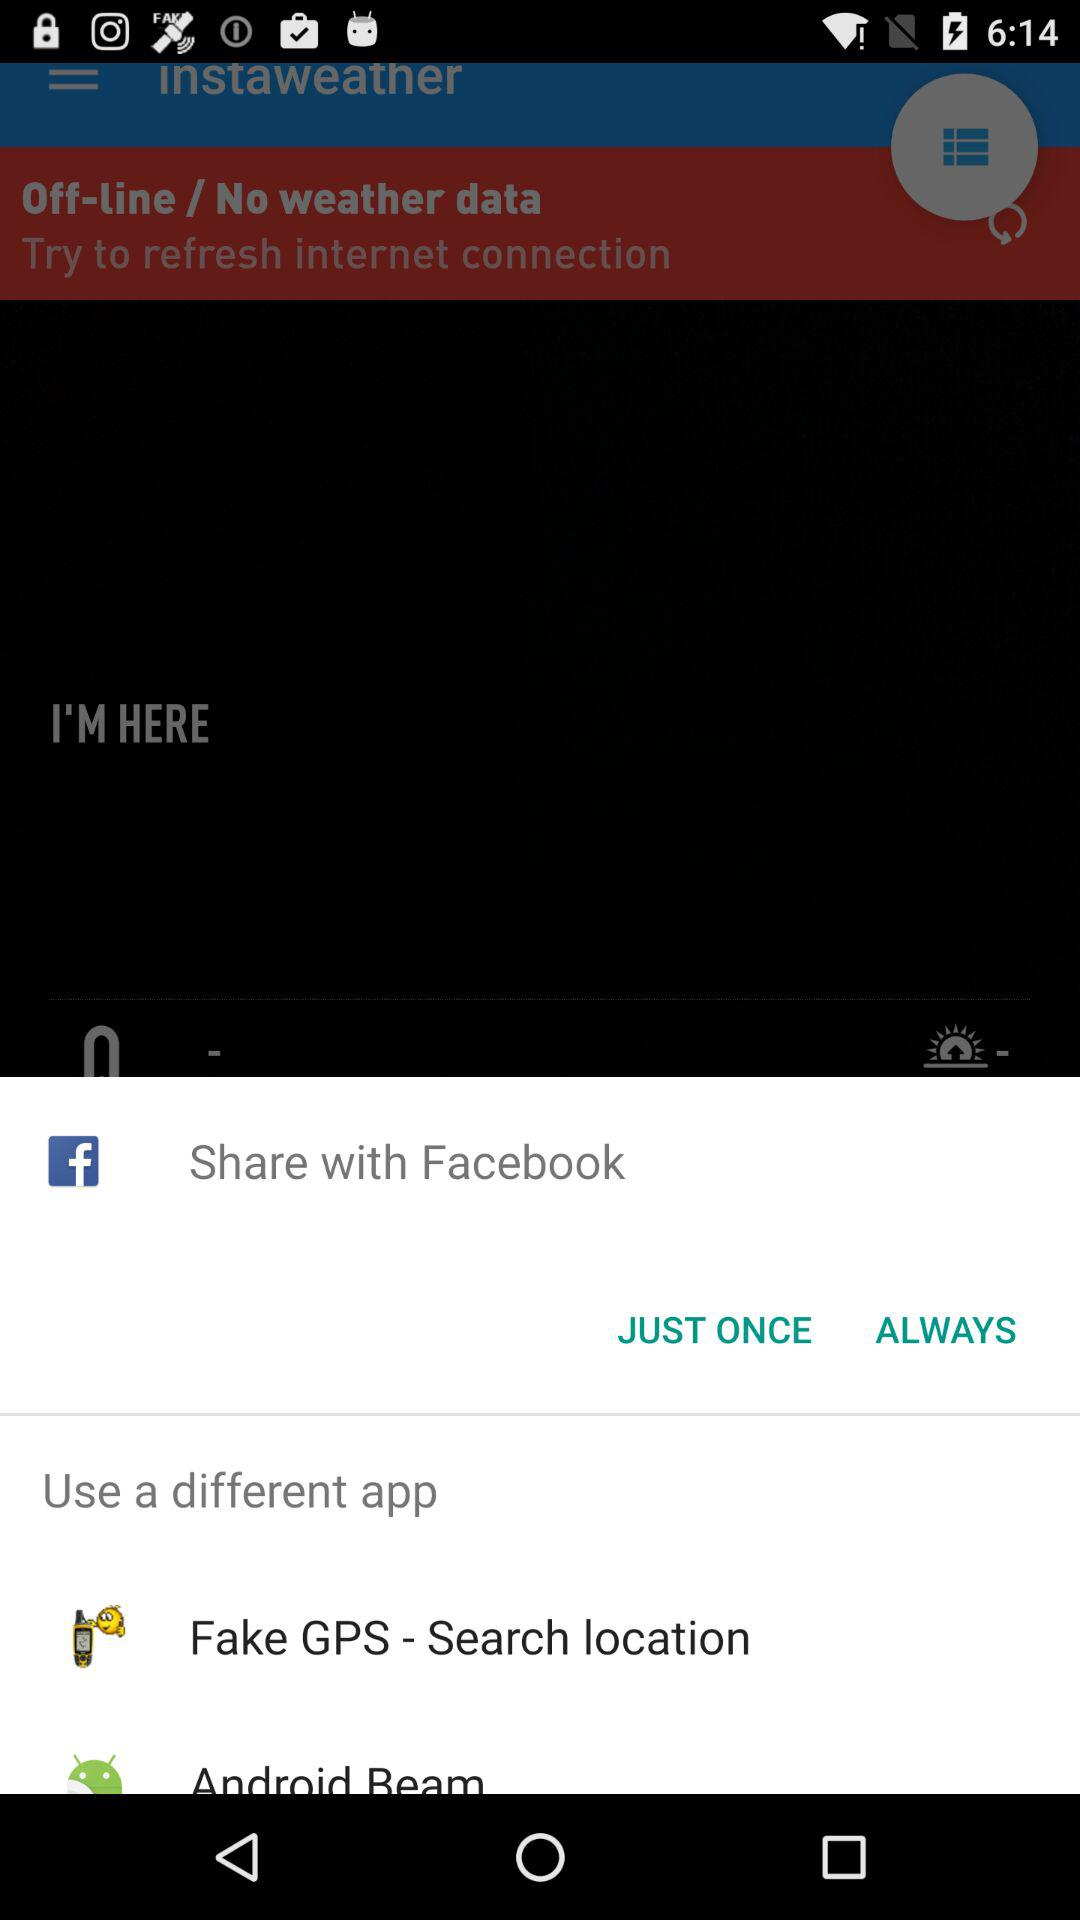What are the different apps I can use? The different apps you can use are "Facebook", "Fake GPS - Search location" and "Android Beam". 